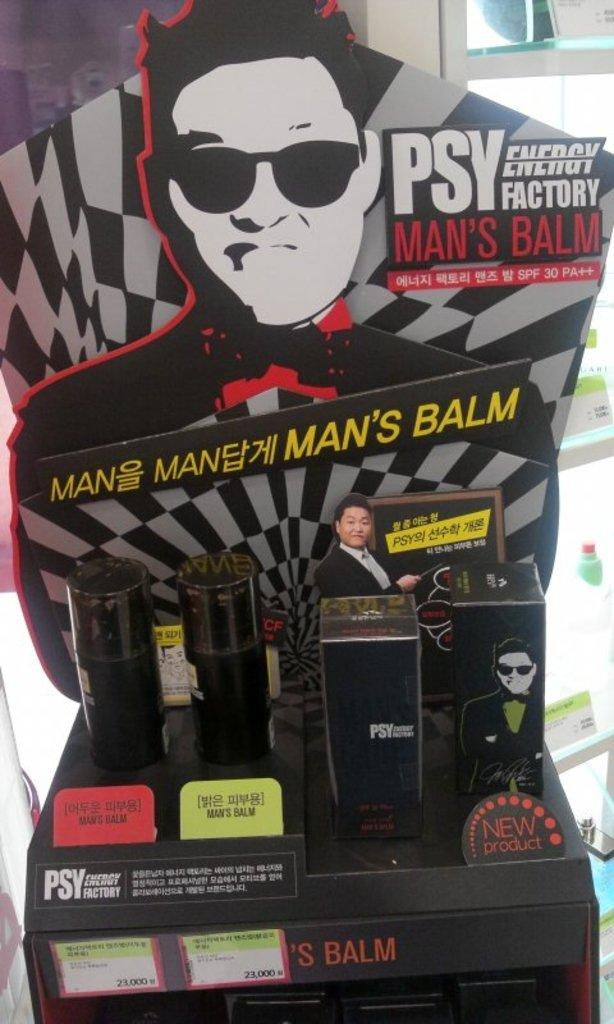<image>
Summarize the visual content of the image. A PSY brand Man's Balm product display with a man's picture on the display 